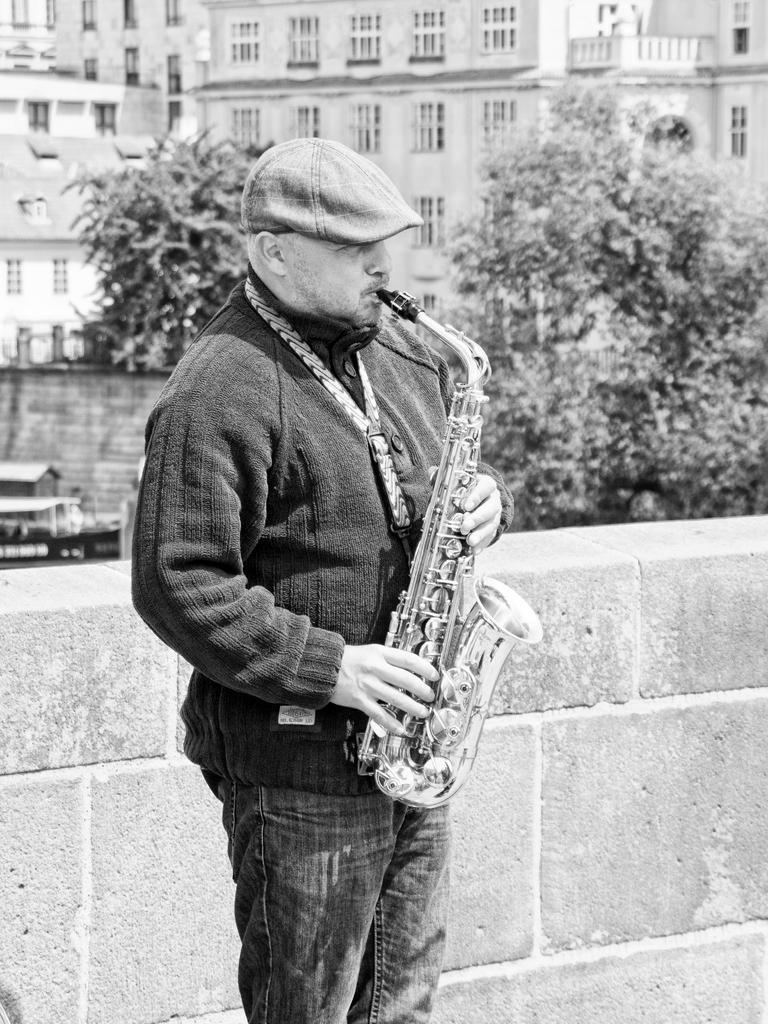Describe this image in one or two sentences. In this image we can see a person playing a saxophone, behind him there is a window, buildings, trees, and the picture is taken in black and white mode. 